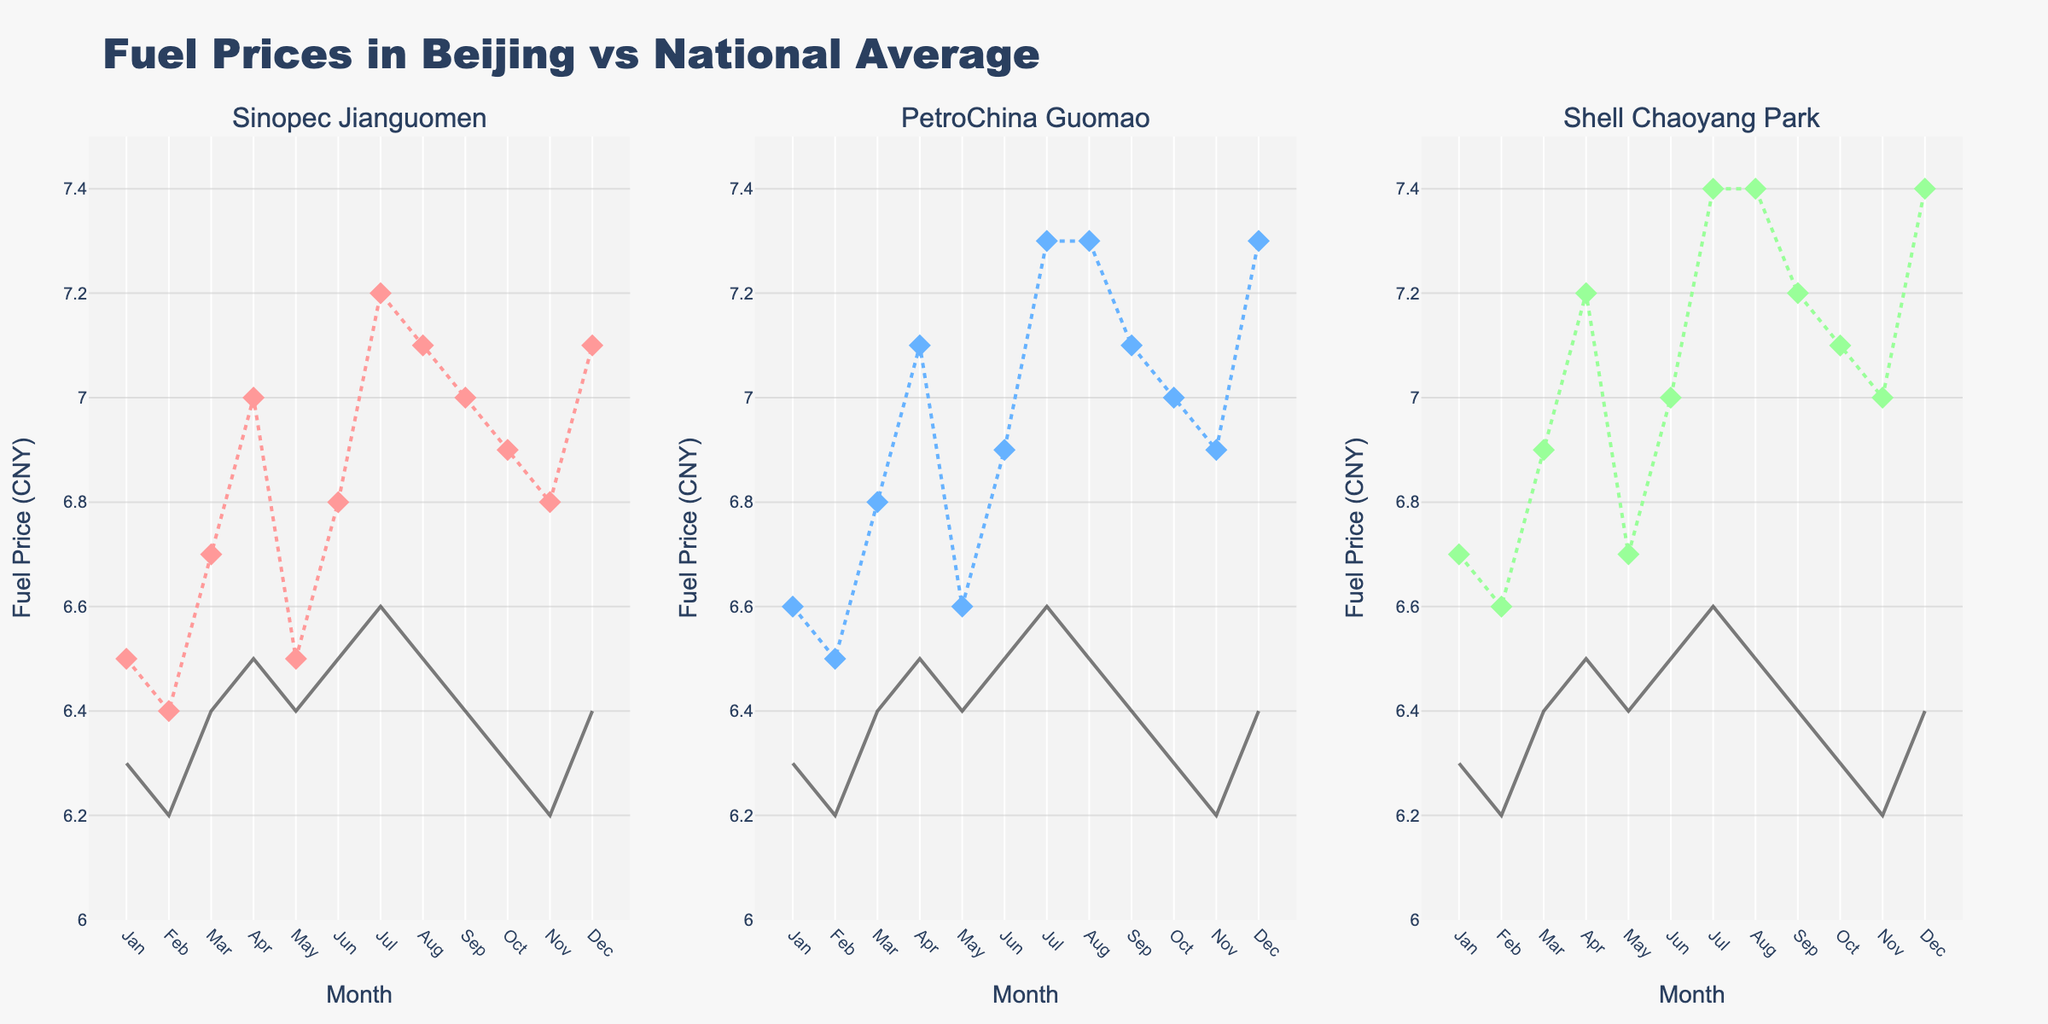Which gas station had the highest fuel price in March? In March, look at the markers (diamond shapes) in the three subplots. The highest fuel price among Sinopec Jianguomen, PetroChina Guomao, and Shell Chaoyang Park in March appears closest to "7" in the Shell Chaoyang Park subplot.
Answer: Shell Chaoyang Park How does the trend of fuel prices at Sinopec Jianguomen compare to the national average throughout the year? Observe the plot for Sinopec Jianguomen and look at both the markers (Sinopec Jianguomen's fuel prices) and the line (national average). The trend for Sinopec Jianguomen is generally higher than the national average across all months.
Answer: Higher than national average Which month showed the greatest increase in fuel price for PetroChina Guomao compared to the previous month? Examine the PetroChina Guomao subplot and compare month-to-month changes by looking at the position of the markers. The largest jump can be seen between June and July.
Answer: June to July Is there any month where all three gas stations had similar fuel prices? Compare the three subplots across each month, looking for months where all the data points (markers) on the vertical axis are close to each other. In January and August, the prices were quite similar at all three stations.
Answer: January, August What is the peak fuel price for Shell Chaoyang Park, and in which month did it occur? Identify the highest point in the Shell Chaoyang Park subplot, represented by the highest marker, which is closest to "7.4". This peak occurs in July.
Answer: 7.4, July During which months did Sinopec Jianguomen fuel prices match the national average? Observe the markers corresponding to Sinopec Jianguomen and the line representing the national average across the subplot. In January, May, and August, Sinopec Jianguomen's prices are closest to the national average.
Answer: January, May, August What is the average fuel price difference between PetroChina Guomao and the national average over the year? Find the difference for each month, sum these differences, and divide by 12 (total months). The differences are: (6.6-6.3) + (6.5-6.2) + (6.8-6.4) + (7.1-6.5) + (6.6-6.4) + (6.9-6.5) + (7.3-6.6) + (7.3-6.5) + (7.1-6.4) + (7.0-6.3) + (6.9-6.2) + (7.3-6.4), which totals 8.4 CNY. The average difference is 8.4/12 ≈ 0.7 CNY.
Answer: 0.7 CNY 